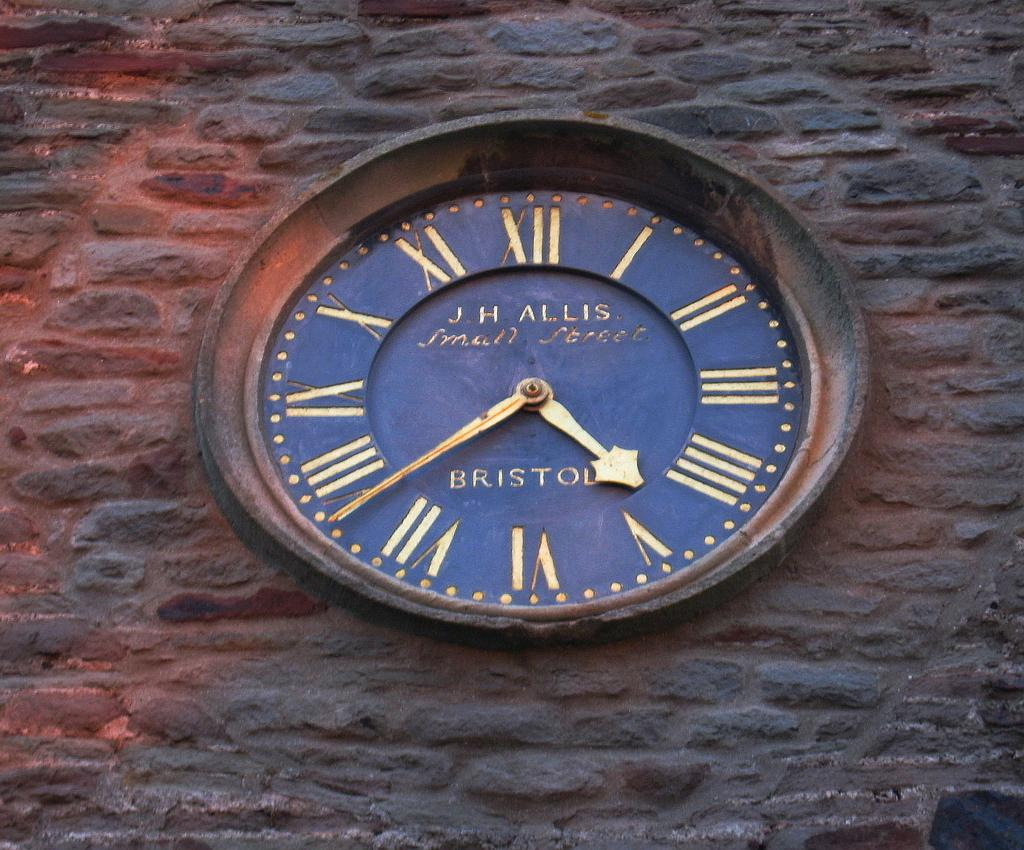<image>
Render a clear and concise summary of the photo. An antique J.H. Allis clock with a rustic border and a navy blue background is depicted. 